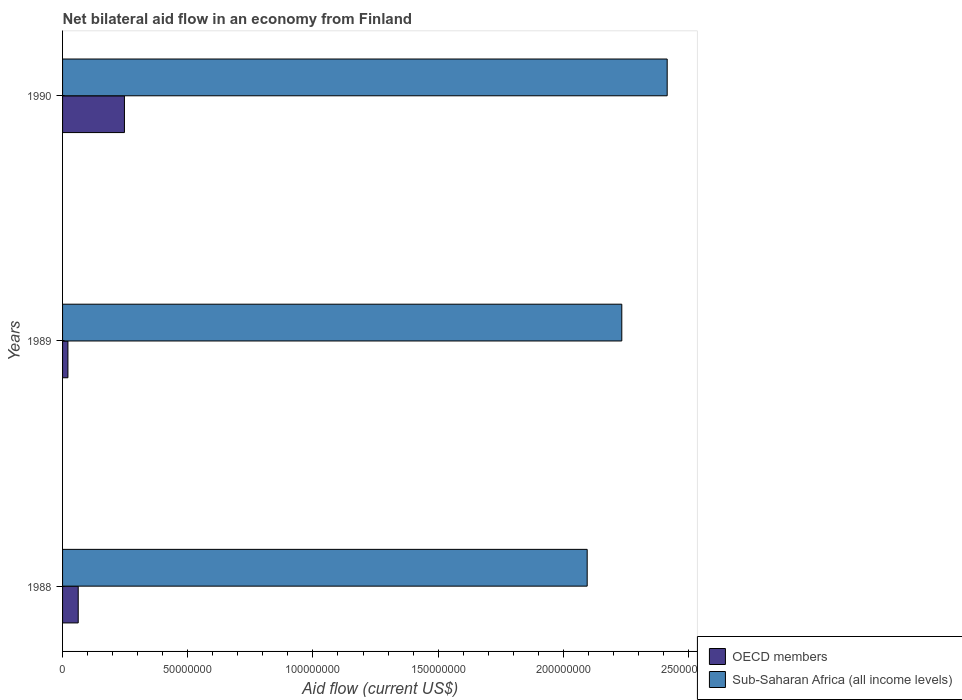How many groups of bars are there?
Give a very brief answer. 3. What is the net bilateral aid flow in OECD members in 1988?
Ensure brevity in your answer.  6.25e+06. Across all years, what is the maximum net bilateral aid flow in OECD members?
Your answer should be very brief. 2.47e+07. Across all years, what is the minimum net bilateral aid flow in Sub-Saharan Africa (all income levels)?
Provide a short and direct response. 2.10e+08. What is the total net bilateral aid flow in OECD members in the graph?
Offer a very short reply. 3.31e+07. What is the difference between the net bilateral aid flow in OECD members in 1988 and that in 1990?
Offer a very short reply. -1.85e+07. What is the difference between the net bilateral aid flow in Sub-Saharan Africa (all income levels) in 1990 and the net bilateral aid flow in OECD members in 1988?
Your response must be concise. 2.35e+08. What is the average net bilateral aid flow in Sub-Saharan Africa (all income levels) per year?
Provide a succinct answer. 2.25e+08. In the year 1989, what is the difference between the net bilateral aid flow in OECD members and net bilateral aid flow in Sub-Saharan Africa (all income levels)?
Provide a succinct answer. -2.21e+08. In how many years, is the net bilateral aid flow in Sub-Saharan Africa (all income levels) greater than 180000000 US$?
Offer a very short reply. 3. What is the ratio of the net bilateral aid flow in Sub-Saharan Africa (all income levels) in 1988 to that in 1990?
Make the answer very short. 0.87. Is the difference between the net bilateral aid flow in OECD members in 1988 and 1990 greater than the difference between the net bilateral aid flow in Sub-Saharan Africa (all income levels) in 1988 and 1990?
Ensure brevity in your answer.  Yes. What is the difference between the highest and the second highest net bilateral aid flow in Sub-Saharan Africa (all income levels)?
Provide a succinct answer. 1.81e+07. What is the difference between the highest and the lowest net bilateral aid flow in Sub-Saharan Africa (all income levels)?
Your answer should be compact. 3.20e+07. In how many years, is the net bilateral aid flow in Sub-Saharan Africa (all income levels) greater than the average net bilateral aid flow in Sub-Saharan Africa (all income levels) taken over all years?
Your answer should be very brief. 1. What does the 1st bar from the top in 1990 represents?
Keep it short and to the point. Sub-Saharan Africa (all income levels). What does the 2nd bar from the bottom in 1988 represents?
Give a very brief answer. Sub-Saharan Africa (all income levels). How many bars are there?
Offer a terse response. 6. What is the difference between two consecutive major ticks on the X-axis?
Make the answer very short. 5.00e+07. Does the graph contain any zero values?
Make the answer very short. No. Where does the legend appear in the graph?
Make the answer very short. Bottom right. How many legend labels are there?
Your answer should be very brief. 2. How are the legend labels stacked?
Keep it short and to the point. Vertical. What is the title of the graph?
Ensure brevity in your answer.  Net bilateral aid flow in an economy from Finland. Does "Lower middle income" appear as one of the legend labels in the graph?
Make the answer very short. No. What is the label or title of the X-axis?
Your answer should be compact. Aid flow (current US$). What is the Aid flow (current US$) in OECD members in 1988?
Ensure brevity in your answer.  6.25e+06. What is the Aid flow (current US$) of Sub-Saharan Africa (all income levels) in 1988?
Your response must be concise. 2.10e+08. What is the Aid flow (current US$) in OECD members in 1989?
Keep it short and to the point. 2.14e+06. What is the Aid flow (current US$) in Sub-Saharan Africa (all income levels) in 1989?
Your response must be concise. 2.23e+08. What is the Aid flow (current US$) in OECD members in 1990?
Keep it short and to the point. 2.47e+07. What is the Aid flow (current US$) of Sub-Saharan Africa (all income levels) in 1990?
Keep it short and to the point. 2.41e+08. Across all years, what is the maximum Aid flow (current US$) in OECD members?
Provide a succinct answer. 2.47e+07. Across all years, what is the maximum Aid flow (current US$) in Sub-Saharan Africa (all income levels)?
Offer a very short reply. 2.41e+08. Across all years, what is the minimum Aid flow (current US$) of OECD members?
Offer a terse response. 2.14e+06. Across all years, what is the minimum Aid flow (current US$) in Sub-Saharan Africa (all income levels)?
Provide a short and direct response. 2.10e+08. What is the total Aid flow (current US$) of OECD members in the graph?
Your answer should be compact. 3.31e+07. What is the total Aid flow (current US$) of Sub-Saharan Africa (all income levels) in the graph?
Your response must be concise. 6.74e+08. What is the difference between the Aid flow (current US$) in OECD members in 1988 and that in 1989?
Offer a terse response. 4.11e+06. What is the difference between the Aid flow (current US$) in Sub-Saharan Africa (all income levels) in 1988 and that in 1989?
Ensure brevity in your answer.  -1.38e+07. What is the difference between the Aid flow (current US$) of OECD members in 1988 and that in 1990?
Keep it short and to the point. -1.85e+07. What is the difference between the Aid flow (current US$) in Sub-Saharan Africa (all income levels) in 1988 and that in 1990?
Provide a succinct answer. -3.20e+07. What is the difference between the Aid flow (current US$) in OECD members in 1989 and that in 1990?
Offer a terse response. -2.26e+07. What is the difference between the Aid flow (current US$) of Sub-Saharan Africa (all income levels) in 1989 and that in 1990?
Provide a short and direct response. -1.81e+07. What is the difference between the Aid flow (current US$) in OECD members in 1988 and the Aid flow (current US$) in Sub-Saharan Africa (all income levels) in 1989?
Provide a short and direct response. -2.17e+08. What is the difference between the Aid flow (current US$) in OECD members in 1988 and the Aid flow (current US$) in Sub-Saharan Africa (all income levels) in 1990?
Your response must be concise. -2.35e+08. What is the difference between the Aid flow (current US$) in OECD members in 1989 and the Aid flow (current US$) in Sub-Saharan Africa (all income levels) in 1990?
Provide a short and direct response. -2.39e+08. What is the average Aid flow (current US$) of OECD members per year?
Your answer should be compact. 1.10e+07. What is the average Aid flow (current US$) in Sub-Saharan Africa (all income levels) per year?
Ensure brevity in your answer.  2.25e+08. In the year 1988, what is the difference between the Aid flow (current US$) in OECD members and Aid flow (current US$) in Sub-Saharan Africa (all income levels)?
Provide a succinct answer. -2.03e+08. In the year 1989, what is the difference between the Aid flow (current US$) of OECD members and Aid flow (current US$) of Sub-Saharan Africa (all income levels)?
Your answer should be very brief. -2.21e+08. In the year 1990, what is the difference between the Aid flow (current US$) in OECD members and Aid flow (current US$) in Sub-Saharan Africa (all income levels)?
Your answer should be very brief. -2.17e+08. What is the ratio of the Aid flow (current US$) in OECD members in 1988 to that in 1989?
Your answer should be very brief. 2.92. What is the ratio of the Aid flow (current US$) in Sub-Saharan Africa (all income levels) in 1988 to that in 1989?
Ensure brevity in your answer.  0.94. What is the ratio of the Aid flow (current US$) of OECD members in 1988 to that in 1990?
Ensure brevity in your answer.  0.25. What is the ratio of the Aid flow (current US$) in Sub-Saharan Africa (all income levels) in 1988 to that in 1990?
Offer a very short reply. 0.87. What is the ratio of the Aid flow (current US$) in OECD members in 1989 to that in 1990?
Offer a terse response. 0.09. What is the ratio of the Aid flow (current US$) in Sub-Saharan Africa (all income levels) in 1989 to that in 1990?
Your answer should be very brief. 0.92. What is the difference between the highest and the second highest Aid flow (current US$) of OECD members?
Provide a short and direct response. 1.85e+07. What is the difference between the highest and the second highest Aid flow (current US$) of Sub-Saharan Africa (all income levels)?
Offer a terse response. 1.81e+07. What is the difference between the highest and the lowest Aid flow (current US$) in OECD members?
Your response must be concise. 2.26e+07. What is the difference between the highest and the lowest Aid flow (current US$) in Sub-Saharan Africa (all income levels)?
Ensure brevity in your answer.  3.20e+07. 